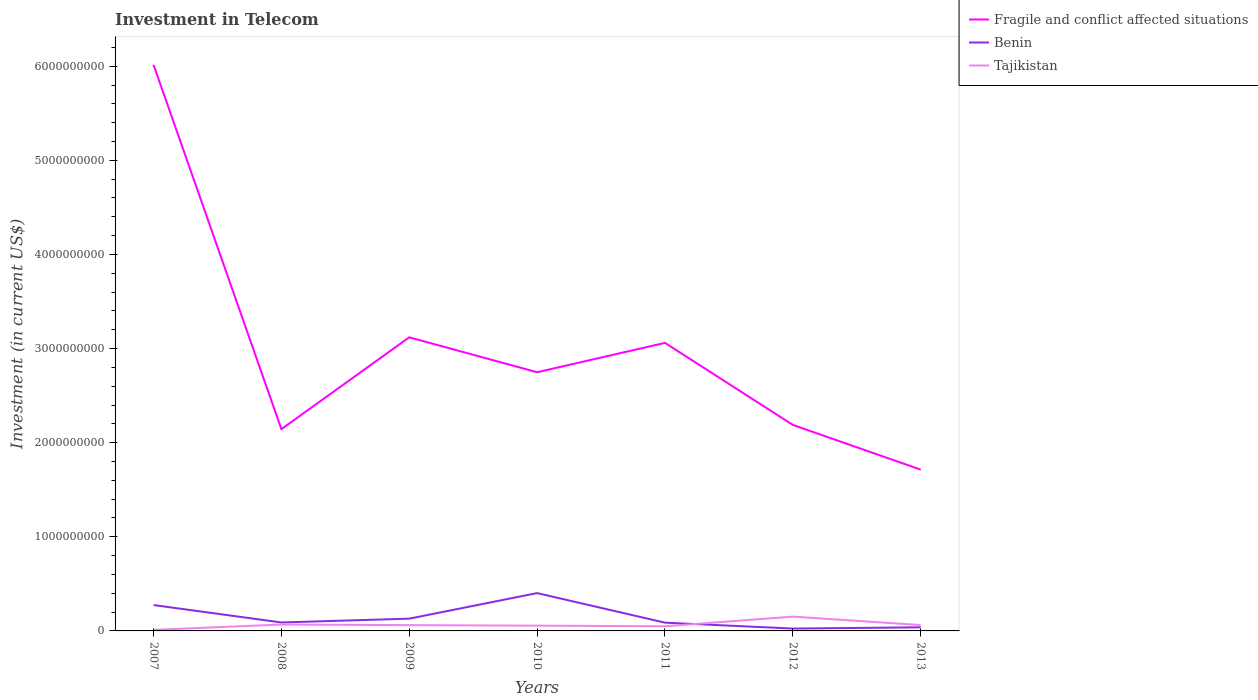How many different coloured lines are there?
Ensure brevity in your answer.  3. Does the line corresponding to Tajikistan intersect with the line corresponding to Benin?
Your answer should be compact. Yes. Is the number of lines equal to the number of legend labels?
Provide a succinct answer. Yes. Across all years, what is the maximum amount invested in telecom in Tajikistan?
Your answer should be compact. 1.10e+07. In which year was the amount invested in telecom in Benin maximum?
Your answer should be compact. 2012. What is the total amount invested in telecom in Tajikistan in the graph?
Provide a succinct answer. -3.84e+07. What is the difference between the highest and the second highest amount invested in telecom in Fragile and conflict affected situations?
Ensure brevity in your answer.  4.30e+09. What is the difference between the highest and the lowest amount invested in telecom in Fragile and conflict affected situations?
Offer a very short reply. 3. What is the difference between two consecutive major ticks on the Y-axis?
Offer a terse response. 1.00e+09. Does the graph contain any zero values?
Your answer should be very brief. No. Does the graph contain grids?
Your response must be concise. No. How many legend labels are there?
Make the answer very short. 3. How are the legend labels stacked?
Offer a very short reply. Vertical. What is the title of the graph?
Give a very brief answer. Investment in Telecom. Does "United States" appear as one of the legend labels in the graph?
Ensure brevity in your answer.  No. What is the label or title of the Y-axis?
Offer a very short reply. Investment (in current US$). What is the Investment (in current US$) in Fragile and conflict affected situations in 2007?
Keep it short and to the point. 6.01e+09. What is the Investment (in current US$) in Benin in 2007?
Offer a very short reply. 2.75e+08. What is the Investment (in current US$) of Tajikistan in 2007?
Keep it short and to the point. 1.10e+07. What is the Investment (in current US$) in Fragile and conflict affected situations in 2008?
Provide a succinct answer. 2.14e+09. What is the Investment (in current US$) of Benin in 2008?
Offer a terse response. 8.98e+07. What is the Investment (in current US$) of Tajikistan in 2008?
Ensure brevity in your answer.  6.80e+07. What is the Investment (in current US$) in Fragile and conflict affected situations in 2009?
Keep it short and to the point. 3.12e+09. What is the Investment (in current US$) in Benin in 2009?
Offer a very short reply. 1.30e+08. What is the Investment (in current US$) in Tajikistan in 2009?
Keep it short and to the point. 6.14e+07. What is the Investment (in current US$) in Fragile and conflict affected situations in 2010?
Give a very brief answer. 2.75e+09. What is the Investment (in current US$) of Benin in 2010?
Ensure brevity in your answer.  4.02e+08. What is the Investment (in current US$) in Tajikistan in 2010?
Keep it short and to the point. 5.60e+07. What is the Investment (in current US$) in Fragile and conflict affected situations in 2011?
Give a very brief answer. 3.06e+09. What is the Investment (in current US$) of Benin in 2011?
Provide a succinct answer. 8.77e+07. What is the Investment (in current US$) of Tajikistan in 2011?
Offer a very short reply. 4.94e+07. What is the Investment (in current US$) of Fragile and conflict affected situations in 2012?
Your response must be concise. 2.19e+09. What is the Investment (in current US$) in Benin in 2012?
Provide a succinct answer. 2.51e+07. What is the Investment (in current US$) in Tajikistan in 2012?
Offer a very short reply. 1.52e+08. What is the Investment (in current US$) in Fragile and conflict affected situations in 2013?
Make the answer very short. 1.71e+09. What is the Investment (in current US$) in Benin in 2013?
Provide a short and direct response. 3.84e+07. What is the Investment (in current US$) of Tajikistan in 2013?
Provide a short and direct response. 6.25e+07. Across all years, what is the maximum Investment (in current US$) in Fragile and conflict affected situations?
Provide a succinct answer. 6.01e+09. Across all years, what is the maximum Investment (in current US$) of Benin?
Your answer should be very brief. 4.02e+08. Across all years, what is the maximum Investment (in current US$) of Tajikistan?
Provide a short and direct response. 1.52e+08. Across all years, what is the minimum Investment (in current US$) in Fragile and conflict affected situations?
Your response must be concise. 1.71e+09. Across all years, what is the minimum Investment (in current US$) of Benin?
Offer a very short reply. 2.51e+07. Across all years, what is the minimum Investment (in current US$) of Tajikistan?
Offer a very short reply. 1.10e+07. What is the total Investment (in current US$) in Fragile and conflict affected situations in the graph?
Your response must be concise. 2.10e+1. What is the total Investment (in current US$) of Benin in the graph?
Ensure brevity in your answer.  1.05e+09. What is the total Investment (in current US$) in Tajikistan in the graph?
Provide a short and direct response. 4.60e+08. What is the difference between the Investment (in current US$) in Fragile and conflict affected situations in 2007 and that in 2008?
Keep it short and to the point. 3.87e+09. What is the difference between the Investment (in current US$) of Benin in 2007 and that in 2008?
Keep it short and to the point. 1.85e+08. What is the difference between the Investment (in current US$) in Tajikistan in 2007 and that in 2008?
Ensure brevity in your answer.  -5.70e+07. What is the difference between the Investment (in current US$) in Fragile and conflict affected situations in 2007 and that in 2009?
Your response must be concise. 2.90e+09. What is the difference between the Investment (in current US$) in Benin in 2007 and that in 2009?
Your answer should be compact. 1.45e+08. What is the difference between the Investment (in current US$) in Tajikistan in 2007 and that in 2009?
Your answer should be very brief. -5.04e+07. What is the difference between the Investment (in current US$) of Fragile and conflict affected situations in 2007 and that in 2010?
Ensure brevity in your answer.  3.27e+09. What is the difference between the Investment (in current US$) in Benin in 2007 and that in 2010?
Give a very brief answer. -1.27e+08. What is the difference between the Investment (in current US$) in Tajikistan in 2007 and that in 2010?
Make the answer very short. -4.50e+07. What is the difference between the Investment (in current US$) in Fragile and conflict affected situations in 2007 and that in 2011?
Provide a short and direct response. 2.95e+09. What is the difference between the Investment (in current US$) in Benin in 2007 and that in 2011?
Offer a terse response. 1.87e+08. What is the difference between the Investment (in current US$) of Tajikistan in 2007 and that in 2011?
Ensure brevity in your answer.  -3.84e+07. What is the difference between the Investment (in current US$) of Fragile and conflict affected situations in 2007 and that in 2012?
Offer a terse response. 3.83e+09. What is the difference between the Investment (in current US$) in Benin in 2007 and that in 2012?
Offer a very short reply. 2.50e+08. What is the difference between the Investment (in current US$) of Tajikistan in 2007 and that in 2012?
Offer a very short reply. -1.41e+08. What is the difference between the Investment (in current US$) of Fragile and conflict affected situations in 2007 and that in 2013?
Offer a very short reply. 4.30e+09. What is the difference between the Investment (in current US$) in Benin in 2007 and that in 2013?
Give a very brief answer. 2.37e+08. What is the difference between the Investment (in current US$) in Tajikistan in 2007 and that in 2013?
Keep it short and to the point. -5.15e+07. What is the difference between the Investment (in current US$) in Fragile and conflict affected situations in 2008 and that in 2009?
Make the answer very short. -9.76e+08. What is the difference between the Investment (in current US$) of Benin in 2008 and that in 2009?
Your answer should be compact. -4.05e+07. What is the difference between the Investment (in current US$) of Tajikistan in 2008 and that in 2009?
Keep it short and to the point. 6.60e+06. What is the difference between the Investment (in current US$) of Fragile and conflict affected situations in 2008 and that in 2010?
Give a very brief answer. -6.05e+08. What is the difference between the Investment (in current US$) of Benin in 2008 and that in 2010?
Provide a succinct answer. -3.12e+08. What is the difference between the Investment (in current US$) in Fragile and conflict affected situations in 2008 and that in 2011?
Provide a succinct answer. -9.16e+08. What is the difference between the Investment (in current US$) of Benin in 2008 and that in 2011?
Offer a terse response. 2.10e+06. What is the difference between the Investment (in current US$) of Tajikistan in 2008 and that in 2011?
Provide a short and direct response. 1.86e+07. What is the difference between the Investment (in current US$) of Fragile and conflict affected situations in 2008 and that in 2012?
Ensure brevity in your answer.  -4.48e+07. What is the difference between the Investment (in current US$) of Benin in 2008 and that in 2012?
Offer a very short reply. 6.47e+07. What is the difference between the Investment (in current US$) in Tajikistan in 2008 and that in 2012?
Ensure brevity in your answer.  -8.38e+07. What is the difference between the Investment (in current US$) of Fragile and conflict affected situations in 2008 and that in 2013?
Keep it short and to the point. 4.30e+08. What is the difference between the Investment (in current US$) in Benin in 2008 and that in 2013?
Your answer should be compact. 5.14e+07. What is the difference between the Investment (in current US$) in Tajikistan in 2008 and that in 2013?
Provide a short and direct response. 5.50e+06. What is the difference between the Investment (in current US$) of Fragile and conflict affected situations in 2009 and that in 2010?
Offer a very short reply. 3.71e+08. What is the difference between the Investment (in current US$) in Benin in 2009 and that in 2010?
Offer a very short reply. -2.72e+08. What is the difference between the Investment (in current US$) in Tajikistan in 2009 and that in 2010?
Offer a very short reply. 5.40e+06. What is the difference between the Investment (in current US$) of Fragile and conflict affected situations in 2009 and that in 2011?
Your answer should be compact. 5.91e+07. What is the difference between the Investment (in current US$) of Benin in 2009 and that in 2011?
Offer a very short reply. 4.26e+07. What is the difference between the Investment (in current US$) of Tajikistan in 2009 and that in 2011?
Your answer should be very brief. 1.20e+07. What is the difference between the Investment (in current US$) of Fragile and conflict affected situations in 2009 and that in 2012?
Ensure brevity in your answer.  9.31e+08. What is the difference between the Investment (in current US$) in Benin in 2009 and that in 2012?
Provide a short and direct response. 1.05e+08. What is the difference between the Investment (in current US$) of Tajikistan in 2009 and that in 2012?
Offer a terse response. -9.04e+07. What is the difference between the Investment (in current US$) in Fragile and conflict affected situations in 2009 and that in 2013?
Make the answer very short. 1.41e+09. What is the difference between the Investment (in current US$) of Benin in 2009 and that in 2013?
Ensure brevity in your answer.  9.19e+07. What is the difference between the Investment (in current US$) in Tajikistan in 2009 and that in 2013?
Your response must be concise. -1.10e+06. What is the difference between the Investment (in current US$) in Fragile and conflict affected situations in 2010 and that in 2011?
Provide a succinct answer. -3.12e+08. What is the difference between the Investment (in current US$) in Benin in 2010 and that in 2011?
Offer a terse response. 3.14e+08. What is the difference between the Investment (in current US$) of Tajikistan in 2010 and that in 2011?
Offer a very short reply. 6.60e+06. What is the difference between the Investment (in current US$) of Fragile and conflict affected situations in 2010 and that in 2012?
Ensure brevity in your answer.  5.60e+08. What is the difference between the Investment (in current US$) of Benin in 2010 and that in 2012?
Offer a terse response. 3.77e+08. What is the difference between the Investment (in current US$) in Tajikistan in 2010 and that in 2012?
Your answer should be compact. -9.58e+07. What is the difference between the Investment (in current US$) in Fragile and conflict affected situations in 2010 and that in 2013?
Your response must be concise. 1.04e+09. What is the difference between the Investment (in current US$) in Benin in 2010 and that in 2013?
Make the answer very short. 3.64e+08. What is the difference between the Investment (in current US$) in Tajikistan in 2010 and that in 2013?
Your answer should be compact. -6.50e+06. What is the difference between the Investment (in current US$) of Fragile and conflict affected situations in 2011 and that in 2012?
Provide a succinct answer. 8.72e+08. What is the difference between the Investment (in current US$) of Benin in 2011 and that in 2012?
Your answer should be very brief. 6.26e+07. What is the difference between the Investment (in current US$) in Tajikistan in 2011 and that in 2012?
Ensure brevity in your answer.  -1.02e+08. What is the difference between the Investment (in current US$) in Fragile and conflict affected situations in 2011 and that in 2013?
Keep it short and to the point. 1.35e+09. What is the difference between the Investment (in current US$) in Benin in 2011 and that in 2013?
Ensure brevity in your answer.  4.93e+07. What is the difference between the Investment (in current US$) in Tajikistan in 2011 and that in 2013?
Keep it short and to the point. -1.31e+07. What is the difference between the Investment (in current US$) in Fragile and conflict affected situations in 2012 and that in 2013?
Make the answer very short. 4.75e+08. What is the difference between the Investment (in current US$) in Benin in 2012 and that in 2013?
Offer a very short reply. -1.33e+07. What is the difference between the Investment (in current US$) of Tajikistan in 2012 and that in 2013?
Offer a very short reply. 8.92e+07. What is the difference between the Investment (in current US$) of Fragile and conflict affected situations in 2007 and the Investment (in current US$) of Benin in 2008?
Offer a terse response. 5.92e+09. What is the difference between the Investment (in current US$) of Fragile and conflict affected situations in 2007 and the Investment (in current US$) of Tajikistan in 2008?
Ensure brevity in your answer.  5.95e+09. What is the difference between the Investment (in current US$) in Benin in 2007 and the Investment (in current US$) in Tajikistan in 2008?
Your answer should be very brief. 2.07e+08. What is the difference between the Investment (in current US$) of Fragile and conflict affected situations in 2007 and the Investment (in current US$) of Benin in 2009?
Offer a terse response. 5.88e+09. What is the difference between the Investment (in current US$) in Fragile and conflict affected situations in 2007 and the Investment (in current US$) in Tajikistan in 2009?
Your response must be concise. 5.95e+09. What is the difference between the Investment (in current US$) of Benin in 2007 and the Investment (in current US$) of Tajikistan in 2009?
Provide a succinct answer. 2.14e+08. What is the difference between the Investment (in current US$) in Fragile and conflict affected situations in 2007 and the Investment (in current US$) in Benin in 2010?
Your response must be concise. 5.61e+09. What is the difference between the Investment (in current US$) in Fragile and conflict affected situations in 2007 and the Investment (in current US$) in Tajikistan in 2010?
Give a very brief answer. 5.96e+09. What is the difference between the Investment (in current US$) of Benin in 2007 and the Investment (in current US$) of Tajikistan in 2010?
Make the answer very short. 2.19e+08. What is the difference between the Investment (in current US$) in Fragile and conflict affected situations in 2007 and the Investment (in current US$) in Benin in 2011?
Your answer should be compact. 5.93e+09. What is the difference between the Investment (in current US$) of Fragile and conflict affected situations in 2007 and the Investment (in current US$) of Tajikistan in 2011?
Ensure brevity in your answer.  5.97e+09. What is the difference between the Investment (in current US$) of Benin in 2007 and the Investment (in current US$) of Tajikistan in 2011?
Offer a very short reply. 2.26e+08. What is the difference between the Investment (in current US$) in Fragile and conflict affected situations in 2007 and the Investment (in current US$) in Benin in 2012?
Provide a short and direct response. 5.99e+09. What is the difference between the Investment (in current US$) of Fragile and conflict affected situations in 2007 and the Investment (in current US$) of Tajikistan in 2012?
Your response must be concise. 5.86e+09. What is the difference between the Investment (in current US$) of Benin in 2007 and the Investment (in current US$) of Tajikistan in 2012?
Provide a short and direct response. 1.23e+08. What is the difference between the Investment (in current US$) of Fragile and conflict affected situations in 2007 and the Investment (in current US$) of Benin in 2013?
Offer a very short reply. 5.98e+09. What is the difference between the Investment (in current US$) of Fragile and conflict affected situations in 2007 and the Investment (in current US$) of Tajikistan in 2013?
Keep it short and to the point. 5.95e+09. What is the difference between the Investment (in current US$) of Benin in 2007 and the Investment (in current US$) of Tajikistan in 2013?
Give a very brief answer. 2.12e+08. What is the difference between the Investment (in current US$) of Fragile and conflict affected situations in 2008 and the Investment (in current US$) of Benin in 2009?
Offer a very short reply. 2.01e+09. What is the difference between the Investment (in current US$) in Fragile and conflict affected situations in 2008 and the Investment (in current US$) in Tajikistan in 2009?
Provide a short and direct response. 2.08e+09. What is the difference between the Investment (in current US$) in Benin in 2008 and the Investment (in current US$) in Tajikistan in 2009?
Your answer should be compact. 2.84e+07. What is the difference between the Investment (in current US$) of Fragile and conflict affected situations in 2008 and the Investment (in current US$) of Benin in 2010?
Ensure brevity in your answer.  1.74e+09. What is the difference between the Investment (in current US$) of Fragile and conflict affected situations in 2008 and the Investment (in current US$) of Tajikistan in 2010?
Make the answer very short. 2.09e+09. What is the difference between the Investment (in current US$) in Benin in 2008 and the Investment (in current US$) in Tajikistan in 2010?
Ensure brevity in your answer.  3.38e+07. What is the difference between the Investment (in current US$) of Fragile and conflict affected situations in 2008 and the Investment (in current US$) of Benin in 2011?
Give a very brief answer. 2.06e+09. What is the difference between the Investment (in current US$) in Fragile and conflict affected situations in 2008 and the Investment (in current US$) in Tajikistan in 2011?
Provide a succinct answer. 2.09e+09. What is the difference between the Investment (in current US$) in Benin in 2008 and the Investment (in current US$) in Tajikistan in 2011?
Keep it short and to the point. 4.04e+07. What is the difference between the Investment (in current US$) in Fragile and conflict affected situations in 2008 and the Investment (in current US$) in Benin in 2012?
Provide a succinct answer. 2.12e+09. What is the difference between the Investment (in current US$) of Fragile and conflict affected situations in 2008 and the Investment (in current US$) of Tajikistan in 2012?
Ensure brevity in your answer.  1.99e+09. What is the difference between the Investment (in current US$) in Benin in 2008 and the Investment (in current US$) in Tajikistan in 2012?
Your answer should be very brief. -6.20e+07. What is the difference between the Investment (in current US$) in Fragile and conflict affected situations in 2008 and the Investment (in current US$) in Benin in 2013?
Your answer should be very brief. 2.11e+09. What is the difference between the Investment (in current US$) in Fragile and conflict affected situations in 2008 and the Investment (in current US$) in Tajikistan in 2013?
Your answer should be very brief. 2.08e+09. What is the difference between the Investment (in current US$) in Benin in 2008 and the Investment (in current US$) in Tajikistan in 2013?
Your answer should be very brief. 2.73e+07. What is the difference between the Investment (in current US$) of Fragile and conflict affected situations in 2009 and the Investment (in current US$) of Benin in 2010?
Offer a terse response. 2.72e+09. What is the difference between the Investment (in current US$) in Fragile and conflict affected situations in 2009 and the Investment (in current US$) in Tajikistan in 2010?
Give a very brief answer. 3.06e+09. What is the difference between the Investment (in current US$) in Benin in 2009 and the Investment (in current US$) in Tajikistan in 2010?
Offer a terse response. 7.43e+07. What is the difference between the Investment (in current US$) of Fragile and conflict affected situations in 2009 and the Investment (in current US$) of Benin in 2011?
Offer a very short reply. 3.03e+09. What is the difference between the Investment (in current US$) of Fragile and conflict affected situations in 2009 and the Investment (in current US$) of Tajikistan in 2011?
Provide a short and direct response. 3.07e+09. What is the difference between the Investment (in current US$) of Benin in 2009 and the Investment (in current US$) of Tajikistan in 2011?
Your answer should be very brief. 8.09e+07. What is the difference between the Investment (in current US$) in Fragile and conflict affected situations in 2009 and the Investment (in current US$) in Benin in 2012?
Your answer should be very brief. 3.09e+09. What is the difference between the Investment (in current US$) of Fragile and conflict affected situations in 2009 and the Investment (in current US$) of Tajikistan in 2012?
Give a very brief answer. 2.97e+09. What is the difference between the Investment (in current US$) of Benin in 2009 and the Investment (in current US$) of Tajikistan in 2012?
Provide a succinct answer. -2.14e+07. What is the difference between the Investment (in current US$) in Fragile and conflict affected situations in 2009 and the Investment (in current US$) in Benin in 2013?
Keep it short and to the point. 3.08e+09. What is the difference between the Investment (in current US$) of Fragile and conflict affected situations in 2009 and the Investment (in current US$) of Tajikistan in 2013?
Ensure brevity in your answer.  3.06e+09. What is the difference between the Investment (in current US$) of Benin in 2009 and the Investment (in current US$) of Tajikistan in 2013?
Keep it short and to the point. 6.78e+07. What is the difference between the Investment (in current US$) in Fragile and conflict affected situations in 2010 and the Investment (in current US$) in Benin in 2011?
Ensure brevity in your answer.  2.66e+09. What is the difference between the Investment (in current US$) in Fragile and conflict affected situations in 2010 and the Investment (in current US$) in Tajikistan in 2011?
Your response must be concise. 2.70e+09. What is the difference between the Investment (in current US$) of Benin in 2010 and the Investment (in current US$) of Tajikistan in 2011?
Provide a succinct answer. 3.52e+08. What is the difference between the Investment (in current US$) of Fragile and conflict affected situations in 2010 and the Investment (in current US$) of Benin in 2012?
Keep it short and to the point. 2.72e+09. What is the difference between the Investment (in current US$) of Fragile and conflict affected situations in 2010 and the Investment (in current US$) of Tajikistan in 2012?
Keep it short and to the point. 2.60e+09. What is the difference between the Investment (in current US$) in Benin in 2010 and the Investment (in current US$) in Tajikistan in 2012?
Give a very brief answer. 2.50e+08. What is the difference between the Investment (in current US$) in Fragile and conflict affected situations in 2010 and the Investment (in current US$) in Benin in 2013?
Offer a very short reply. 2.71e+09. What is the difference between the Investment (in current US$) in Fragile and conflict affected situations in 2010 and the Investment (in current US$) in Tajikistan in 2013?
Your answer should be very brief. 2.69e+09. What is the difference between the Investment (in current US$) of Benin in 2010 and the Investment (in current US$) of Tajikistan in 2013?
Offer a terse response. 3.39e+08. What is the difference between the Investment (in current US$) of Fragile and conflict affected situations in 2011 and the Investment (in current US$) of Benin in 2012?
Keep it short and to the point. 3.04e+09. What is the difference between the Investment (in current US$) of Fragile and conflict affected situations in 2011 and the Investment (in current US$) of Tajikistan in 2012?
Ensure brevity in your answer.  2.91e+09. What is the difference between the Investment (in current US$) of Benin in 2011 and the Investment (in current US$) of Tajikistan in 2012?
Your response must be concise. -6.40e+07. What is the difference between the Investment (in current US$) of Fragile and conflict affected situations in 2011 and the Investment (in current US$) of Benin in 2013?
Your answer should be compact. 3.02e+09. What is the difference between the Investment (in current US$) in Fragile and conflict affected situations in 2011 and the Investment (in current US$) in Tajikistan in 2013?
Ensure brevity in your answer.  3.00e+09. What is the difference between the Investment (in current US$) of Benin in 2011 and the Investment (in current US$) of Tajikistan in 2013?
Make the answer very short. 2.52e+07. What is the difference between the Investment (in current US$) of Fragile and conflict affected situations in 2012 and the Investment (in current US$) of Benin in 2013?
Give a very brief answer. 2.15e+09. What is the difference between the Investment (in current US$) of Fragile and conflict affected situations in 2012 and the Investment (in current US$) of Tajikistan in 2013?
Your response must be concise. 2.13e+09. What is the difference between the Investment (in current US$) in Benin in 2012 and the Investment (in current US$) in Tajikistan in 2013?
Offer a terse response. -3.74e+07. What is the average Investment (in current US$) of Fragile and conflict affected situations per year?
Offer a very short reply. 3.00e+09. What is the average Investment (in current US$) in Benin per year?
Provide a succinct answer. 1.50e+08. What is the average Investment (in current US$) in Tajikistan per year?
Your answer should be very brief. 6.57e+07. In the year 2007, what is the difference between the Investment (in current US$) in Fragile and conflict affected situations and Investment (in current US$) in Benin?
Provide a short and direct response. 5.74e+09. In the year 2007, what is the difference between the Investment (in current US$) in Fragile and conflict affected situations and Investment (in current US$) in Tajikistan?
Offer a terse response. 6.00e+09. In the year 2007, what is the difference between the Investment (in current US$) in Benin and Investment (in current US$) in Tajikistan?
Offer a very short reply. 2.64e+08. In the year 2008, what is the difference between the Investment (in current US$) in Fragile and conflict affected situations and Investment (in current US$) in Benin?
Make the answer very short. 2.05e+09. In the year 2008, what is the difference between the Investment (in current US$) in Fragile and conflict affected situations and Investment (in current US$) in Tajikistan?
Your answer should be compact. 2.08e+09. In the year 2008, what is the difference between the Investment (in current US$) of Benin and Investment (in current US$) of Tajikistan?
Provide a short and direct response. 2.18e+07. In the year 2009, what is the difference between the Investment (in current US$) of Fragile and conflict affected situations and Investment (in current US$) of Benin?
Offer a very short reply. 2.99e+09. In the year 2009, what is the difference between the Investment (in current US$) of Fragile and conflict affected situations and Investment (in current US$) of Tajikistan?
Offer a terse response. 3.06e+09. In the year 2009, what is the difference between the Investment (in current US$) of Benin and Investment (in current US$) of Tajikistan?
Keep it short and to the point. 6.89e+07. In the year 2010, what is the difference between the Investment (in current US$) of Fragile and conflict affected situations and Investment (in current US$) of Benin?
Provide a succinct answer. 2.35e+09. In the year 2010, what is the difference between the Investment (in current US$) of Fragile and conflict affected situations and Investment (in current US$) of Tajikistan?
Provide a succinct answer. 2.69e+09. In the year 2010, what is the difference between the Investment (in current US$) of Benin and Investment (in current US$) of Tajikistan?
Provide a succinct answer. 3.46e+08. In the year 2011, what is the difference between the Investment (in current US$) in Fragile and conflict affected situations and Investment (in current US$) in Benin?
Offer a terse response. 2.97e+09. In the year 2011, what is the difference between the Investment (in current US$) in Fragile and conflict affected situations and Investment (in current US$) in Tajikistan?
Your answer should be compact. 3.01e+09. In the year 2011, what is the difference between the Investment (in current US$) in Benin and Investment (in current US$) in Tajikistan?
Make the answer very short. 3.83e+07. In the year 2012, what is the difference between the Investment (in current US$) of Fragile and conflict affected situations and Investment (in current US$) of Benin?
Ensure brevity in your answer.  2.16e+09. In the year 2012, what is the difference between the Investment (in current US$) of Fragile and conflict affected situations and Investment (in current US$) of Tajikistan?
Ensure brevity in your answer.  2.04e+09. In the year 2012, what is the difference between the Investment (in current US$) in Benin and Investment (in current US$) in Tajikistan?
Keep it short and to the point. -1.27e+08. In the year 2013, what is the difference between the Investment (in current US$) in Fragile and conflict affected situations and Investment (in current US$) in Benin?
Provide a succinct answer. 1.68e+09. In the year 2013, what is the difference between the Investment (in current US$) of Fragile and conflict affected situations and Investment (in current US$) of Tajikistan?
Keep it short and to the point. 1.65e+09. In the year 2013, what is the difference between the Investment (in current US$) in Benin and Investment (in current US$) in Tajikistan?
Ensure brevity in your answer.  -2.41e+07. What is the ratio of the Investment (in current US$) in Fragile and conflict affected situations in 2007 to that in 2008?
Provide a succinct answer. 2.81. What is the ratio of the Investment (in current US$) of Benin in 2007 to that in 2008?
Your answer should be very brief. 3.06. What is the ratio of the Investment (in current US$) in Tajikistan in 2007 to that in 2008?
Provide a short and direct response. 0.16. What is the ratio of the Investment (in current US$) of Fragile and conflict affected situations in 2007 to that in 2009?
Keep it short and to the point. 1.93. What is the ratio of the Investment (in current US$) in Benin in 2007 to that in 2009?
Keep it short and to the point. 2.11. What is the ratio of the Investment (in current US$) in Tajikistan in 2007 to that in 2009?
Ensure brevity in your answer.  0.18. What is the ratio of the Investment (in current US$) of Fragile and conflict affected situations in 2007 to that in 2010?
Offer a terse response. 2.19. What is the ratio of the Investment (in current US$) in Benin in 2007 to that in 2010?
Your answer should be compact. 0.68. What is the ratio of the Investment (in current US$) of Tajikistan in 2007 to that in 2010?
Provide a short and direct response. 0.2. What is the ratio of the Investment (in current US$) of Fragile and conflict affected situations in 2007 to that in 2011?
Offer a very short reply. 1.97. What is the ratio of the Investment (in current US$) of Benin in 2007 to that in 2011?
Your response must be concise. 3.14. What is the ratio of the Investment (in current US$) in Tajikistan in 2007 to that in 2011?
Your answer should be very brief. 0.22. What is the ratio of the Investment (in current US$) of Fragile and conflict affected situations in 2007 to that in 2012?
Provide a succinct answer. 2.75. What is the ratio of the Investment (in current US$) of Benin in 2007 to that in 2012?
Your answer should be compact. 10.96. What is the ratio of the Investment (in current US$) in Tajikistan in 2007 to that in 2012?
Give a very brief answer. 0.07. What is the ratio of the Investment (in current US$) in Fragile and conflict affected situations in 2007 to that in 2013?
Keep it short and to the point. 3.51. What is the ratio of the Investment (in current US$) in Benin in 2007 to that in 2013?
Your answer should be very brief. 7.16. What is the ratio of the Investment (in current US$) in Tajikistan in 2007 to that in 2013?
Keep it short and to the point. 0.18. What is the ratio of the Investment (in current US$) in Fragile and conflict affected situations in 2008 to that in 2009?
Your answer should be very brief. 0.69. What is the ratio of the Investment (in current US$) in Benin in 2008 to that in 2009?
Ensure brevity in your answer.  0.69. What is the ratio of the Investment (in current US$) in Tajikistan in 2008 to that in 2009?
Give a very brief answer. 1.11. What is the ratio of the Investment (in current US$) of Fragile and conflict affected situations in 2008 to that in 2010?
Ensure brevity in your answer.  0.78. What is the ratio of the Investment (in current US$) of Benin in 2008 to that in 2010?
Offer a very short reply. 0.22. What is the ratio of the Investment (in current US$) in Tajikistan in 2008 to that in 2010?
Give a very brief answer. 1.21. What is the ratio of the Investment (in current US$) of Fragile and conflict affected situations in 2008 to that in 2011?
Your response must be concise. 0.7. What is the ratio of the Investment (in current US$) of Benin in 2008 to that in 2011?
Give a very brief answer. 1.02. What is the ratio of the Investment (in current US$) in Tajikistan in 2008 to that in 2011?
Provide a short and direct response. 1.38. What is the ratio of the Investment (in current US$) of Fragile and conflict affected situations in 2008 to that in 2012?
Make the answer very short. 0.98. What is the ratio of the Investment (in current US$) of Benin in 2008 to that in 2012?
Provide a short and direct response. 3.58. What is the ratio of the Investment (in current US$) of Tajikistan in 2008 to that in 2012?
Provide a succinct answer. 0.45. What is the ratio of the Investment (in current US$) of Fragile and conflict affected situations in 2008 to that in 2013?
Your answer should be compact. 1.25. What is the ratio of the Investment (in current US$) of Benin in 2008 to that in 2013?
Your answer should be very brief. 2.34. What is the ratio of the Investment (in current US$) in Tajikistan in 2008 to that in 2013?
Your answer should be very brief. 1.09. What is the ratio of the Investment (in current US$) of Fragile and conflict affected situations in 2009 to that in 2010?
Keep it short and to the point. 1.13. What is the ratio of the Investment (in current US$) of Benin in 2009 to that in 2010?
Your response must be concise. 0.32. What is the ratio of the Investment (in current US$) in Tajikistan in 2009 to that in 2010?
Your response must be concise. 1.1. What is the ratio of the Investment (in current US$) in Fragile and conflict affected situations in 2009 to that in 2011?
Keep it short and to the point. 1.02. What is the ratio of the Investment (in current US$) of Benin in 2009 to that in 2011?
Provide a succinct answer. 1.49. What is the ratio of the Investment (in current US$) of Tajikistan in 2009 to that in 2011?
Ensure brevity in your answer.  1.24. What is the ratio of the Investment (in current US$) in Fragile and conflict affected situations in 2009 to that in 2012?
Keep it short and to the point. 1.43. What is the ratio of the Investment (in current US$) of Benin in 2009 to that in 2012?
Your answer should be compact. 5.19. What is the ratio of the Investment (in current US$) of Tajikistan in 2009 to that in 2012?
Make the answer very short. 0.4. What is the ratio of the Investment (in current US$) in Fragile and conflict affected situations in 2009 to that in 2013?
Ensure brevity in your answer.  1.82. What is the ratio of the Investment (in current US$) of Benin in 2009 to that in 2013?
Keep it short and to the point. 3.39. What is the ratio of the Investment (in current US$) of Tajikistan in 2009 to that in 2013?
Offer a very short reply. 0.98. What is the ratio of the Investment (in current US$) in Fragile and conflict affected situations in 2010 to that in 2011?
Offer a very short reply. 0.9. What is the ratio of the Investment (in current US$) in Benin in 2010 to that in 2011?
Make the answer very short. 4.58. What is the ratio of the Investment (in current US$) of Tajikistan in 2010 to that in 2011?
Keep it short and to the point. 1.13. What is the ratio of the Investment (in current US$) of Fragile and conflict affected situations in 2010 to that in 2012?
Keep it short and to the point. 1.26. What is the ratio of the Investment (in current US$) in Benin in 2010 to that in 2012?
Give a very brief answer. 16.01. What is the ratio of the Investment (in current US$) of Tajikistan in 2010 to that in 2012?
Provide a short and direct response. 0.37. What is the ratio of the Investment (in current US$) in Fragile and conflict affected situations in 2010 to that in 2013?
Your answer should be very brief. 1.6. What is the ratio of the Investment (in current US$) of Benin in 2010 to that in 2013?
Your answer should be compact. 10.47. What is the ratio of the Investment (in current US$) of Tajikistan in 2010 to that in 2013?
Offer a terse response. 0.9. What is the ratio of the Investment (in current US$) in Fragile and conflict affected situations in 2011 to that in 2012?
Ensure brevity in your answer.  1.4. What is the ratio of the Investment (in current US$) of Benin in 2011 to that in 2012?
Your answer should be compact. 3.49. What is the ratio of the Investment (in current US$) in Tajikistan in 2011 to that in 2012?
Your answer should be compact. 0.33. What is the ratio of the Investment (in current US$) of Fragile and conflict affected situations in 2011 to that in 2013?
Provide a succinct answer. 1.79. What is the ratio of the Investment (in current US$) of Benin in 2011 to that in 2013?
Keep it short and to the point. 2.28. What is the ratio of the Investment (in current US$) of Tajikistan in 2011 to that in 2013?
Make the answer very short. 0.79. What is the ratio of the Investment (in current US$) in Fragile and conflict affected situations in 2012 to that in 2013?
Offer a terse response. 1.28. What is the ratio of the Investment (in current US$) in Benin in 2012 to that in 2013?
Provide a short and direct response. 0.65. What is the ratio of the Investment (in current US$) of Tajikistan in 2012 to that in 2013?
Make the answer very short. 2.43. What is the difference between the highest and the second highest Investment (in current US$) in Fragile and conflict affected situations?
Provide a short and direct response. 2.90e+09. What is the difference between the highest and the second highest Investment (in current US$) of Benin?
Your response must be concise. 1.27e+08. What is the difference between the highest and the second highest Investment (in current US$) in Tajikistan?
Provide a short and direct response. 8.38e+07. What is the difference between the highest and the lowest Investment (in current US$) in Fragile and conflict affected situations?
Your answer should be compact. 4.30e+09. What is the difference between the highest and the lowest Investment (in current US$) in Benin?
Ensure brevity in your answer.  3.77e+08. What is the difference between the highest and the lowest Investment (in current US$) of Tajikistan?
Your response must be concise. 1.41e+08. 